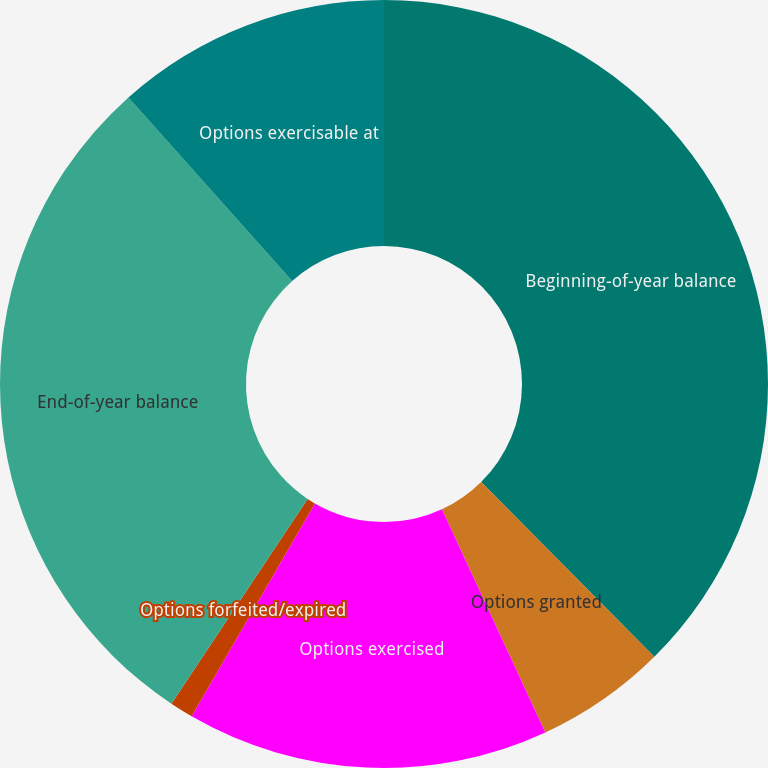Convert chart to OTSL. <chart><loc_0><loc_0><loc_500><loc_500><pie_chart><fcel>Beginning-of-year balance<fcel>Options granted<fcel>Options exercised<fcel>Options forfeited/expired<fcel>End-of-year balance<fcel>Options exercisable at<nl><fcel>37.57%<fcel>5.53%<fcel>15.25%<fcel>0.99%<fcel>29.07%<fcel>11.59%<nl></chart> 